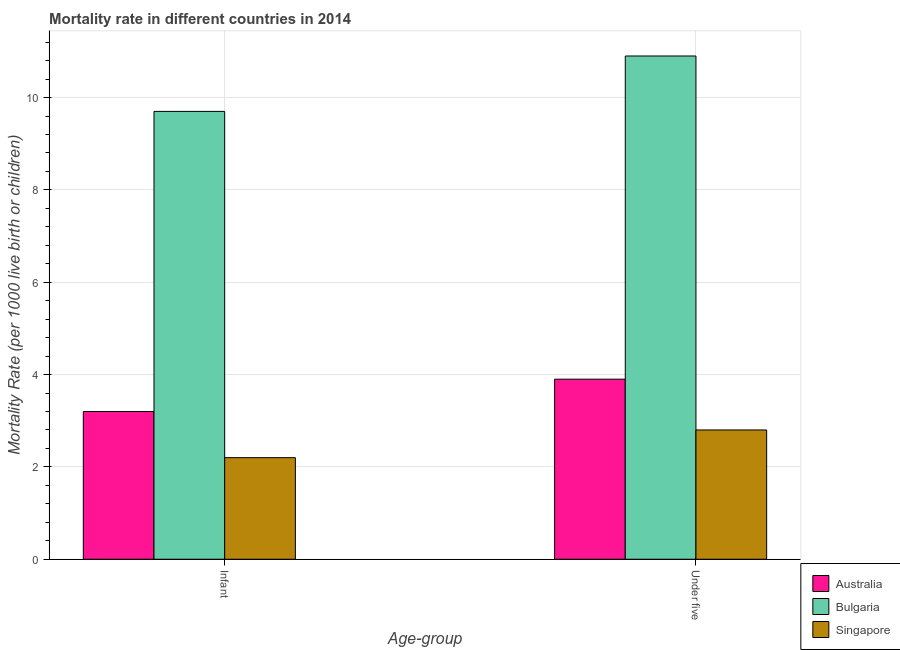How many groups of bars are there?
Offer a terse response. 2. Are the number of bars per tick equal to the number of legend labels?
Keep it short and to the point. Yes. How many bars are there on the 2nd tick from the left?
Keep it short and to the point. 3. What is the label of the 2nd group of bars from the left?
Provide a succinct answer. Under five. In which country was the infant mortality rate minimum?
Make the answer very short. Singapore. What is the total infant mortality rate in the graph?
Provide a short and direct response. 15.1. What is the difference between the infant mortality rate in Singapore and the under-5 mortality rate in Australia?
Ensure brevity in your answer.  -1.7. What is the average under-5 mortality rate per country?
Your response must be concise. 5.87. What is the difference between the infant mortality rate and under-5 mortality rate in Australia?
Your answer should be very brief. -0.7. In how many countries, is the under-5 mortality rate greater than 8.4 ?
Your response must be concise. 1. What is the ratio of the under-5 mortality rate in Singapore to that in Bulgaria?
Provide a short and direct response. 0.26. In how many countries, is the infant mortality rate greater than the average infant mortality rate taken over all countries?
Provide a short and direct response. 1. What does the 1st bar from the left in Under five represents?
Ensure brevity in your answer.  Australia. What does the 3rd bar from the right in Under five represents?
Provide a succinct answer. Australia. How many bars are there?
Your answer should be compact. 6. How many countries are there in the graph?
Give a very brief answer. 3. What is the difference between two consecutive major ticks on the Y-axis?
Your answer should be very brief. 2. Are the values on the major ticks of Y-axis written in scientific E-notation?
Give a very brief answer. No. Does the graph contain grids?
Your answer should be very brief. Yes. Where does the legend appear in the graph?
Your answer should be very brief. Bottom right. How many legend labels are there?
Your answer should be very brief. 3. What is the title of the graph?
Provide a short and direct response. Mortality rate in different countries in 2014. Does "Middle East & North Africa (all income levels)" appear as one of the legend labels in the graph?
Your answer should be compact. No. What is the label or title of the X-axis?
Provide a short and direct response. Age-group. What is the label or title of the Y-axis?
Keep it short and to the point. Mortality Rate (per 1000 live birth or children). What is the Mortality Rate (per 1000 live birth or children) of Australia in Infant?
Make the answer very short. 3.2. What is the Mortality Rate (per 1000 live birth or children) of Bulgaria in Infant?
Ensure brevity in your answer.  9.7. What is the Mortality Rate (per 1000 live birth or children) in Singapore in Infant?
Keep it short and to the point. 2.2. What is the Mortality Rate (per 1000 live birth or children) in Australia in Under five?
Provide a succinct answer. 3.9. What is the Mortality Rate (per 1000 live birth or children) in Bulgaria in Under five?
Provide a succinct answer. 10.9. Across all Age-group, what is the minimum Mortality Rate (per 1000 live birth or children) in Singapore?
Offer a very short reply. 2.2. What is the total Mortality Rate (per 1000 live birth or children) in Australia in the graph?
Provide a succinct answer. 7.1. What is the total Mortality Rate (per 1000 live birth or children) in Bulgaria in the graph?
Make the answer very short. 20.6. What is the difference between the Mortality Rate (per 1000 live birth or children) of Australia in Infant and that in Under five?
Provide a succinct answer. -0.7. What is the difference between the Mortality Rate (per 1000 live birth or children) of Bulgaria in Infant and that in Under five?
Provide a short and direct response. -1.2. What is the difference between the Mortality Rate (per 1000 live birth or children) in Singapore in Infant and that in Under five?
Provide a short and direct response. -0.6. What is the difference between the Mortality Rate (per 1000 live birth or children) in Australia in Infant and the Mortality Rate (per 1000 live birth or children) in Bulgaria in Under five?
Make the answer very short. -7.7. What is the difference between the Mortality Rate (per 1000 live birth or children) of Australia in Infant and the Mortality Rate (per 1000 live birth or children) of Singapore in Under five?
Your answer should be compact. 0.4. What is the difference between the Mortality Rate (per 1000 live birth or children) in Bulgaria in Infant and the Mortality Rate (per 1000 live birth or children) in Singapore in Under five?
Your answer should be very brief. 6.9. What is the average Mortality Rate (per 1000 live birth or children) in Australia per Age-group?
Provide a succinct answer. 3.55. What is the average Mortality Rate (per 1000 live birth or children) in Bulgaria per Age-group?
Offer a very short reply. 10.3. What is the average Mortality Rate (per 1000 live birth or children) in Singapore per Age-group?
Offer a terse response. 2.5. What is the difference between the Mortality Rate (per 1000 live birth or children) in Australia and Mortality Rate (per 1000 live birth or children) in Singapore in Infant?
Give a very brief answer. 1. What is the difference between the Mortality Rate (per 1000 live birth or children) of Bulgaria and Mortality Rate (per 1000 live birth or children) of Singapore in Infant?
Give a very brief answer. 7.5. What is the difference between the Mortality Rate (per 1000 live birth or children) of Australia and Mortality Rate (per 1000 live birth or children) of Bulgaria in Under five?
Ensure brevity in your answer.  -7. What is the difference between the Mortality Rate (per 1000 live birth or children) in Australia and Mortality Rate (per 1000 live birth or children) in Singapore in Under five?
Your answer should be very brief. 1.1. What is the ratio of the Mortality Rate (per 1000 live birth or children) in Australia in Infant to that in Under five?
Your response must be concise. 0.82. What is the ratio of the Mortality Rate (per 1000 live birth or children) in Bulgaria in Infant to that in Under five?
Your answer should be compact. 0.89. What is the ratio of the Mortality Rate (per 1000 live birth or children) in Singapore in Infant to that in Under five?
Your response must be concise. 0.79. What is the difference between the highest and the second highest Mortality Rate (per 1000 live birth or children) of Bulgaria?
Make the answer very short. 1.2. What is the difference between the highest and the second highest Mortality Rate (per 1000 live birth or children) of Singapore?
Ensure brevity in your answer.  0.6. What is the difference between the highest and the lowest Mortality Rate (per 1000 live birth or children) in Australia?
Your answer should be compact. 0.7. What is the difference between the highest and the lowest Mortality Rate (per 1000 live birth or children) in Bulgaria?
Make the answer very short. 1.2. 